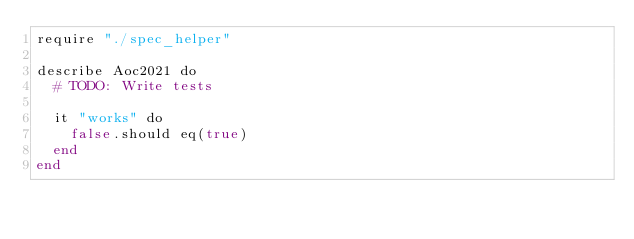<code> <loc_0><loc_0><loc_500><loc_500><_Crystal_>require "./spec_helper"

describe Aoc2021 do
  # TODO: Write tests

  it "works" do
    false.should eq(true)
  end
end
</code> 